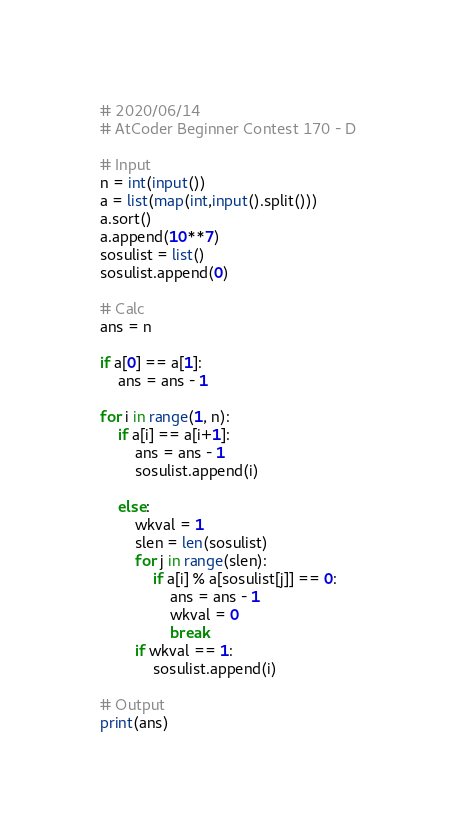Convert code to text. <code><loc_0><loc_0><loc_500><loc_500><_Python_># 2020/06/14
# AtCoder Beginner Contest 170 - D

# Input
n = int(input())
a = list(map(int,input().split()))
a.sort()
a.append(10**7)
sosulist = list()
sosulist.append(0)

# Calc
ans = n

if a[0] == a[1]:
    ans = ans - 1

for i in range(1, n):
    if a[i] == a[i+1]:
        ans = ans - 1
        sosulist.append(i)

    else:
        wkval = 1
        slen = len(sosulist)
        for j in range(slen):
            if a[i] % a[sosulist[j]] == 0:
                ans = ans - 1
                wkval = 0
                break
        if wkval == 1:
            sosulist.append(i)

# Output
print(ans)
</code> 